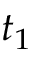<formula> <loc_0><loc_0><loc_500><loc_500>t _ { 1 }</formula> 